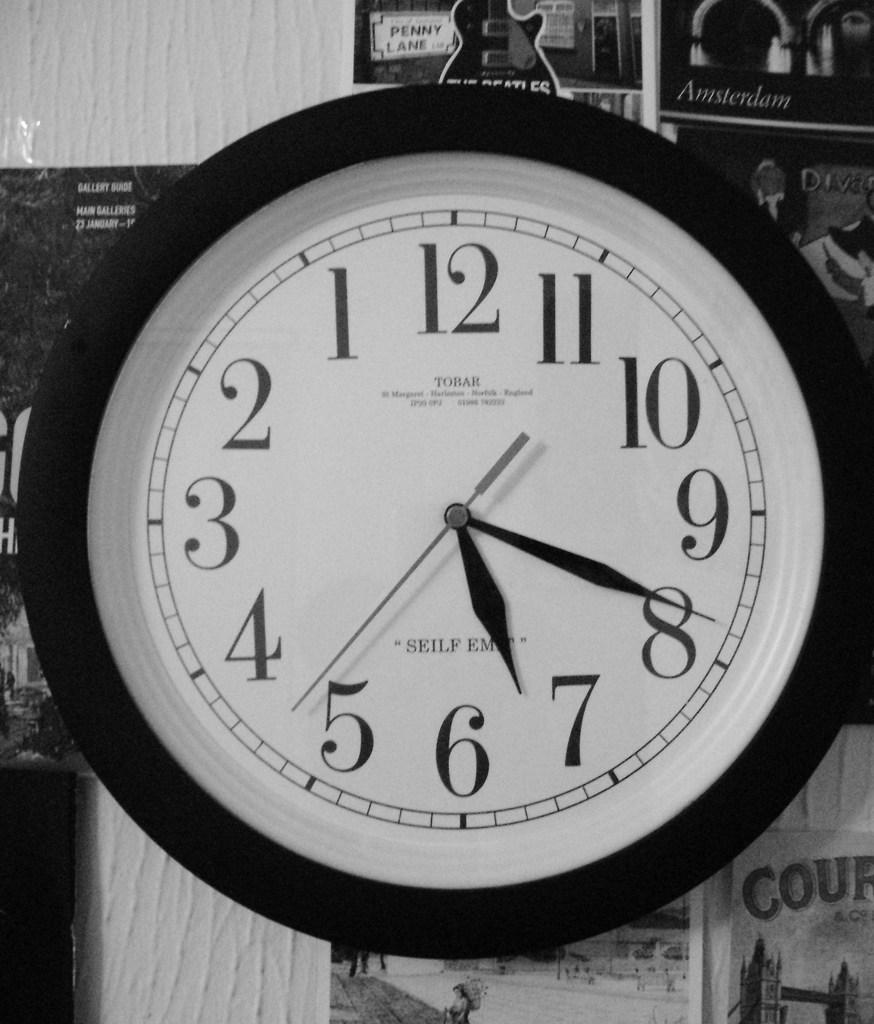<image>
Create a compact narrative representing the image presented. Clock which has the words TOBAR on the top under the number 12. 